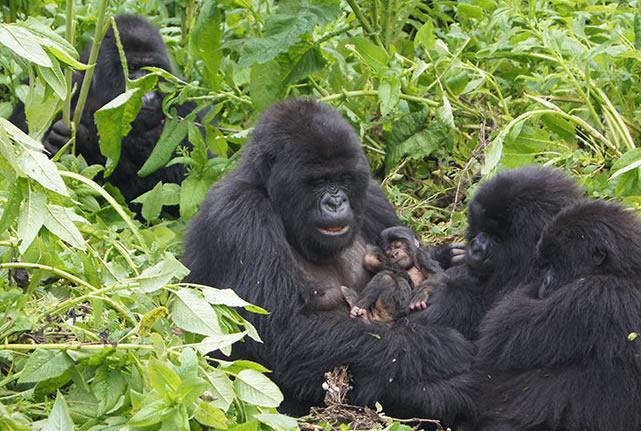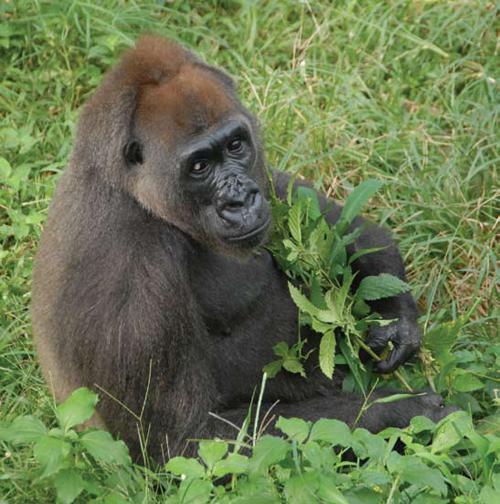The first image is the image on the left, the second image is the image on the right. For the images displayed, is the sentence "One of the images contain only one gorrilla." factually correct? Answer yes or no. Yes. The first image is the image on the left, the second image is the image on the right. Examine the images to the left and right. Is the description "One of the images features an adult gorilla carrying a baby gorilla." accurate? Answer yes or no. Yes. 